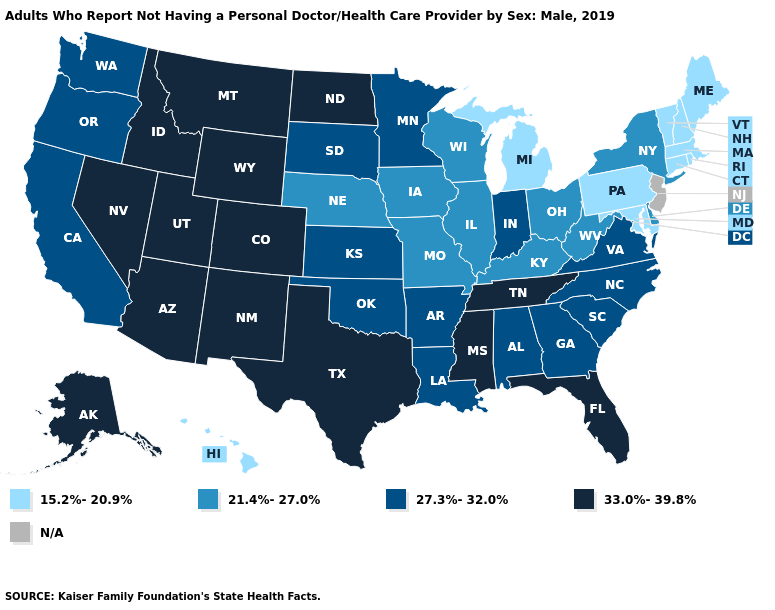What is the highest value in the USA?
Keep it brief. 33.0%-39.8%. Among the states that border Ohio , does Indiana have the highest value?
Give a very brief answer. Yes. How many symbols are there in the legend?
Keep it brief. 5. Name the states that have a value in the range 15.2%-20.9%?
Concise answer only. Connecticut, Hawaii, Maine, Maryland, Massachusetts, Michigan, New Hampshire, Pennsylvania, Rhode Island, Vermont. Does the map have missing data?
Short answer required. Yes. What is the value of Louisiana?
Be succinct. 27.3%-32.0%. Name the states that have a value in the range 21.4%-27.0%?
Give a very brief answer. Delaware, Illinois, Iowa, Kentucky, Missouri, Nebraska, New York, Ohio, West Virginia, Wisconsin. What is the lowest value in states that border Wyoming?
Answer briefly. 21.4%-27.0%. Name the states that have a value in the range 33.0%-39.8%?
Keep it brief. Alaska, Arizona, Colorado, Florida, Idaho, Mississippi, Montana, Nevada, New Mexico, North Dakota, Tennessee, Texas, Utah, Wyoming. Which states have the highest value in the USA?
Concise answer only. Alaska, Arizona, Colorado, Florida, Idaho, Mississippi, Montana, Nevada, New Mexico, North Dakota, Tennessee, Texas, Utah, Wyoming. What is the highest value in states that border Illinois?
Answer briefly. 27.3%-32.0%. Does Oregon have the lowest value in the West?
Short answer required. No. Among the states that border Mississippi , which have the lowest value?
Short answer required. Alabama, Arkansas, Louisiana. 